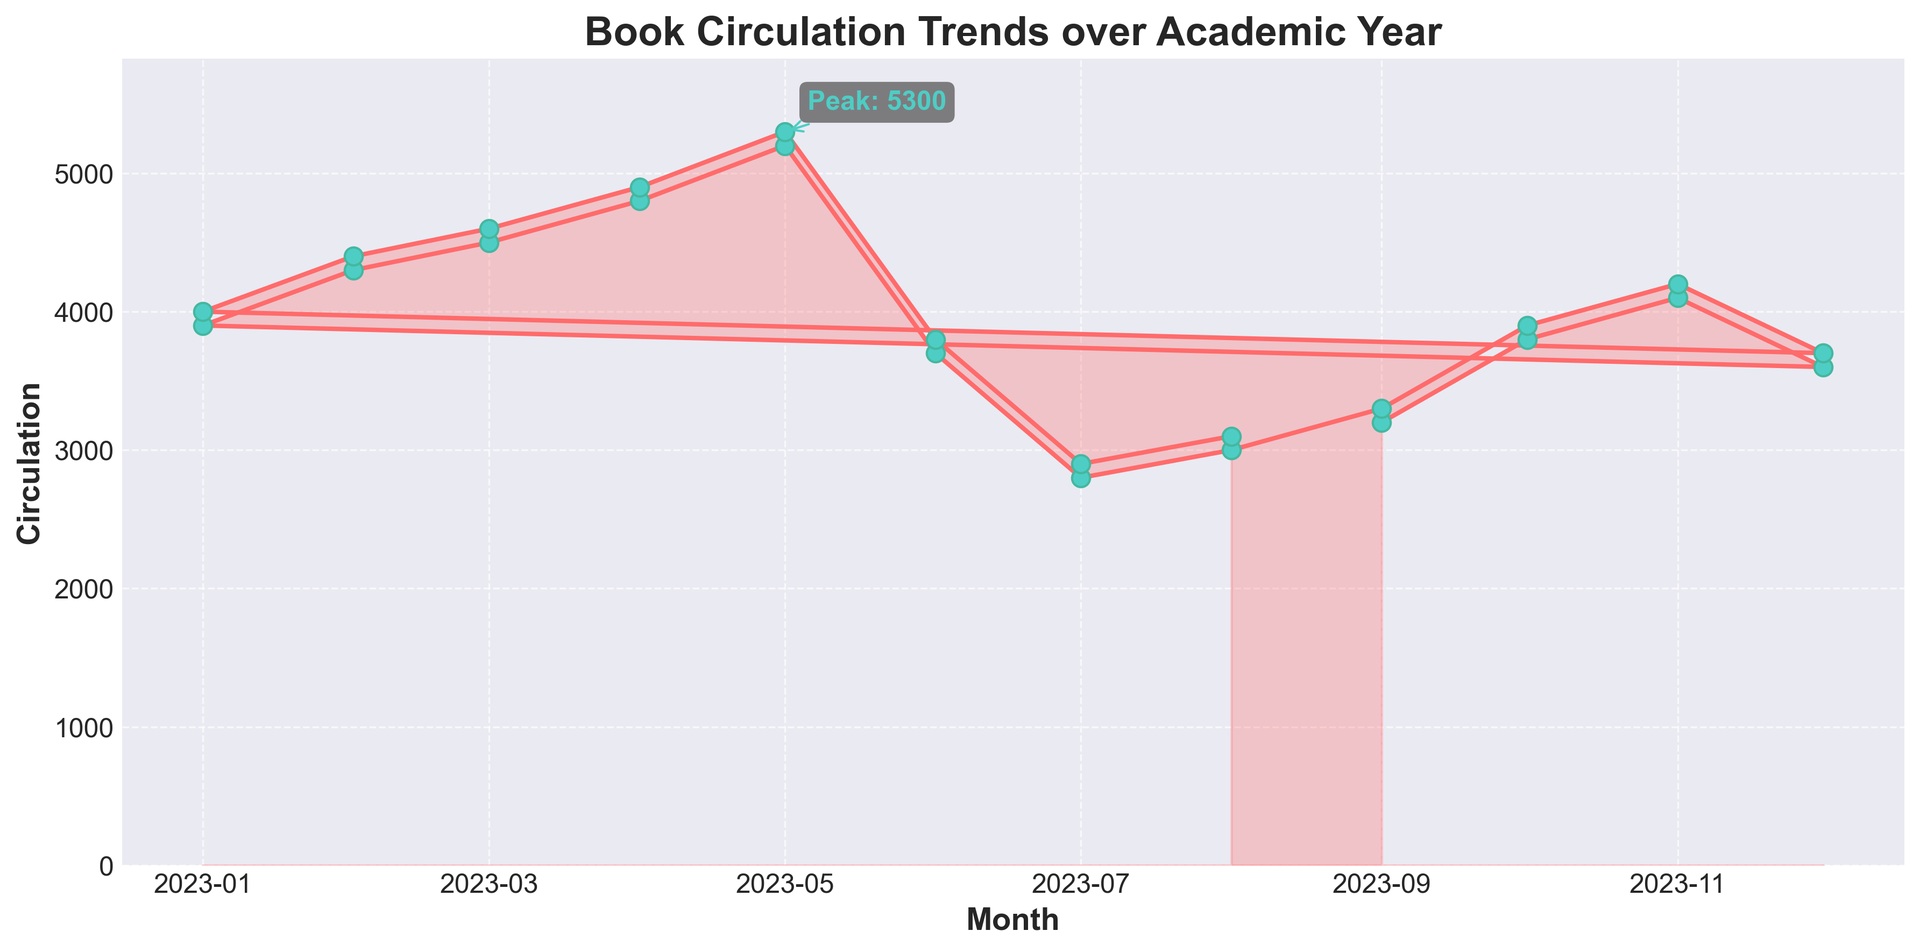What's the peak book circulation value and in which month does it occur? The annotation on the figure marks the peak book circulation value along with the corresponding month. The text annotation next to the peak value makes it easy to identify.
Answer: 5300 in May How does book circulation in February compare to July? By observing the heights of the graph at February and July, it's clear that the circulation in February is much higher than in July. The values are approximately 4400 in February and 2900 in July.
Answer: February is higher What is the overall trend of book circulation from September to May? From the plot, book circulation generally increases from September to May. Examine the slope and markers: starting at around 3200 in September and peaking at 5300 in May with some fluctuations.
Answer: Increasing trend What's the difference in book circulation between April and August? Look at the plotted values. April has a circulation of about 4900, and August is around 3100. Subtract 3100 from 4900 to find the difference.
Answer: 1800 During which months do you observe a decrease in book circulation? By tracking the downward slopes on the plot, it is evident that circulation decreases in June (from May), July (from June), and August (slight increase, then decrease from September). Notable decreases occur: May to June, June to July.
Answer: June, July What is the average circulation from September to December? Sum the circulation values from September to December: 3200 + 3800 + 4100 + 3600 = 14700. Then divide by the number of months (4).
Answer: 3675 How do the circulation values in the two different periods of December compare to each other? Look at both December values: one is 3600 and the other is 3700. Compare them directly.
Answer: 3700 is higher than 3600 What visual elements help specify the highest circulation point? The plot includes an annotation next to the highest point with text and an arrow indicating it. Additionally, the point is marked where the line reaches its maximum.
Answer: Text annotation and arrow By how much does book circulation increase from January to February? Examine the plot for January and February values. January has about 3900, and February is around 4300. Subtract 3900 from 4300.
Answer: 400 Which month marks the beginning of a decrease after a consistent increase? Starting from a noticeable consistent increase from February to April, observe the subsequent drop, which starts rigorously after May.
Answer: June What color is used to highlight the area under the circulation curve? The shaded area under the curve can be observed visually.
Answer: Light red 